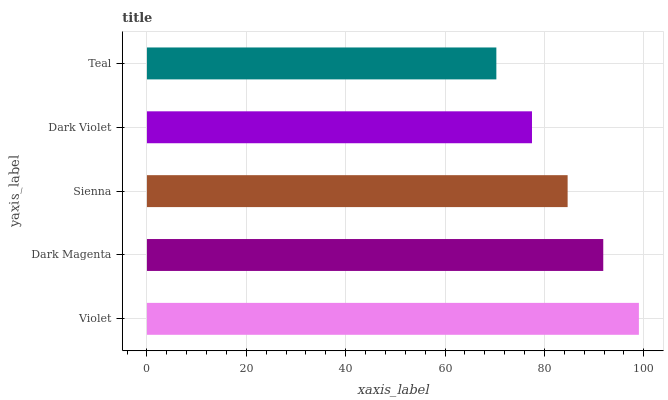Is Teal the minimum?
Answer yes or no. Yes. Is Violet the maximum?
Answer yes or no. Yes. Is Dark Magenta the minimum?
Answer yes or no. No. Is Dark Magenta the maximum?
Answer yes or no. No. Is Violet greater than Dark Magenta?
Answer yes or no. Yes. Is Dark Magenta less than Violet?
Answer yes or no. Yes. Is Dark Magenta greater than Violet?
Answer yes or no. No. Is Violet less than Dark Magenta?
Answer yes or no. No. Is Sienna the high median?
Answer yes or no. Yes. Is Sienna the low median?
Answer yes or no. Yes. Is Violet the high median?
Answer yes or no. No. Is Dark Violet the low median?
Answer yes or no. No. 